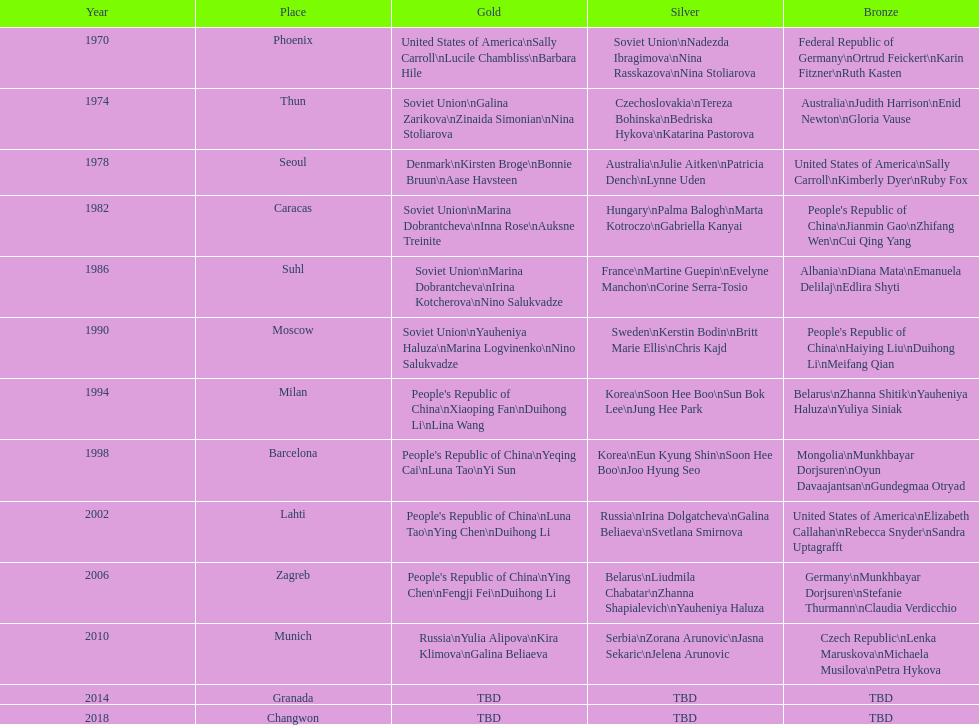Which country is listed the most under the silver column? Korea. 